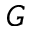<formula> <loc_0><loc_0><loc_500><loc_500>G</formula> 